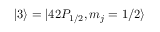<formula> <loc_0><loc_0><loc_500><loc_500>| 3 \rangle = | 4 2 P _ { 1 / 2 } , m _ { j } = 1 / 2 \rangle</formula> 